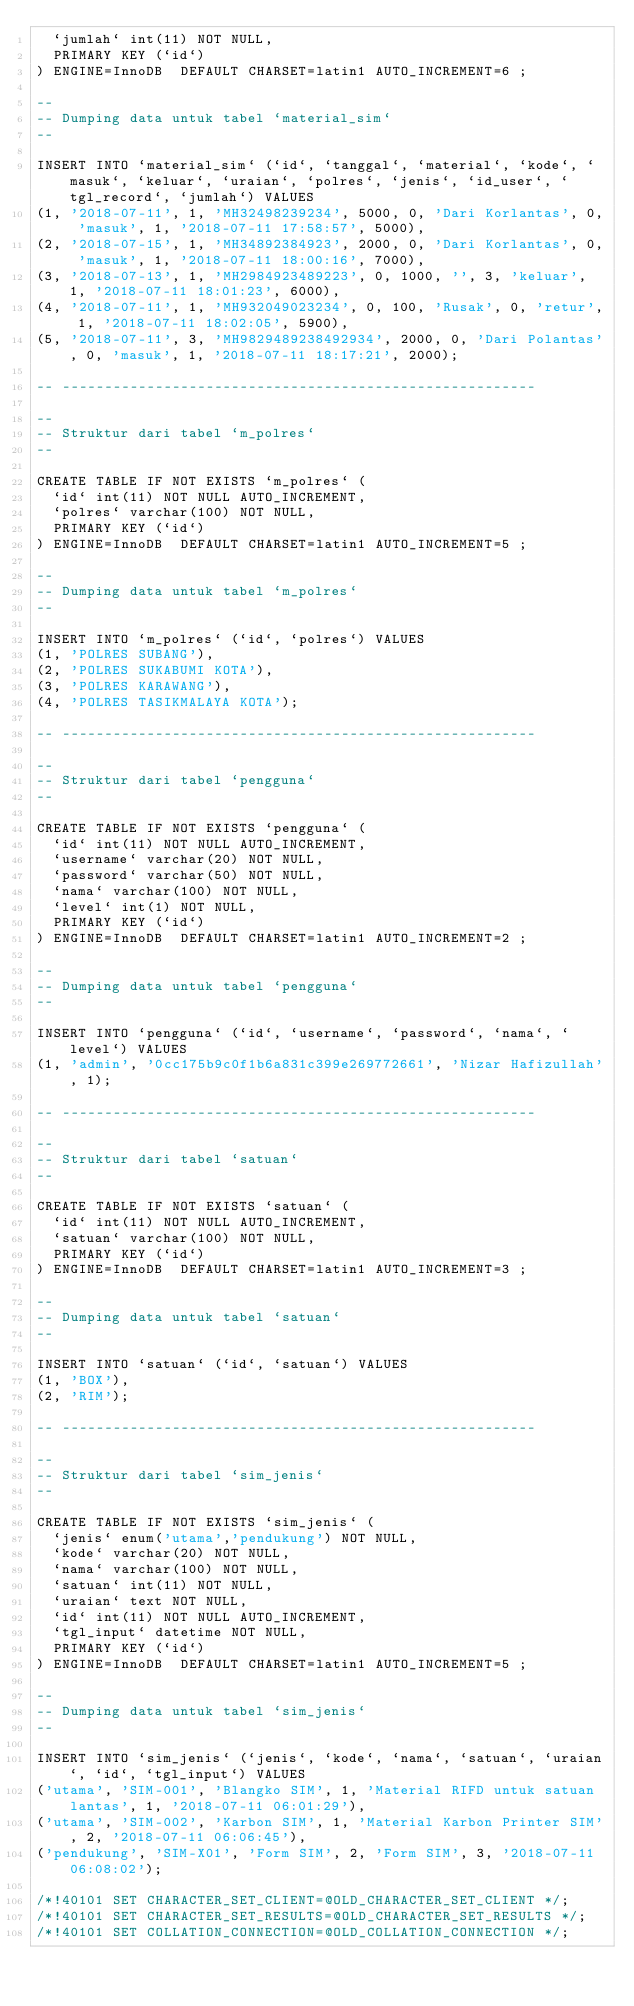Convert code to text. <code><loc_0><loc_0><loc_500><loc_500><_SQL_>  `jumlah` int(11) NOT NULL,
  PRIMARY KEY (`id`)
) ENGINE=InnoDB  DEFAULT CHARSET=latin1 AUTO_INCREMENT=6 ;

--
-- Dumping data untuk tabel `material_sim`
--

INSERT INTO `material_sim` (`id`, `tanggal`, `material`, `kode`, `masuk`, `keluar`, `uraian`, `polres`, `jenis`, `id_user`, `tgl_record`, `jumlah`) VALUES
(1, '2018-07-11', 1, 'MH32498239234', 5000, 0, 'Dari Korlantas', 0, 'masuk', 1, '2018-07-11 17:58:57', 5000),
(2, '2018-07-15', 1, 'MH34892384923', 2000, 0, 'Dari Korlantas', 0, 'masuk', 1, '2018-07-11 18:00:16', 7000),
(3, '2018-07-13', 1, 'MH2984923489223', 0, 1000, '', 3, 'keluar', 1, '2018-07-11 18:01:23', 6000),
(4, '2018-07-11', 1, 'MH932049023234', 0, 100, 'Rusak', 0, 'retur', 1, '2018-07-11 18:02:05', 5900),
(5, '2018-07-11', 3, 'MH9829489238492934', 2000, 0, 'Dari Polantas', 0, 'masuk', 1, '2018-07-11 18:17:21', 2000);

-- --------------------------------------------------------

--
-- Struktur dari tabel `m_polres`
--

CREATE TABLE IF NOT EXISTS `m_polres` (
  `id` int(11) NOT NULL AUTO_INCREMENT,
  `polres` varchar(100) NOT NULL,
  PRIMARY KEY (`id`)
) ENGINE=InnoDB  DEFAULT CHARSET=latin1 AUTO_INCREMENT=5 ;

--
-- Dumping data untuk tabel `m_polres`
--

INSERT INTO `m_polres` (`id`, `polres`) VALUES
(1, 'POLRES SUBANG'),
(2, 'POLRES SUKABUMI KOTA'),
(3, 'POLRES KARAWANG'),
(4, 'POLRES TASIKMALAYA KOTA');

-- --------------------------------------------------------

--
-- Struktur dari tabel `pengguna`
--

CREATE TABLE IF NOT EXISTS `pengguna` (
  `id` int(11) NOT NULL AUTO_INCREMENT,
  `username` varchar(20) NOT NULL,
  `password` varchar(50) NOT NULL,
  `nama` varchar(100) NOT NULL,
  `level` int(1) NOT NULL,
  PRIMARY KEY (`id`)
) ENGINE=InnoDB  DEFAULT CHARSET=latin1 AUTO_INCREMENT=2 ;

--
-- Dumping data untuk tabel `pengguna`
--

INSERT INTO `pengguna` (`id`, `username`, `password`, `nama`, `level`) VALUES
(1, 'admin', '0cc175b9c0f1b6a831c399e269772661', 'Nizar Hafizullah', 1);

-- --------------------------------------------------------

--
-- Struktur dari tabel `satuan`
--

CREATE TABLE IF NOT EXISTS `satuan` (
  `id` int(11) NOT NULL AUTO_INCREMENT,
  `satuan` varchar(100) NOT NULL,
  PRIMARY KEY (`id`)
) ENGINE=InnoDB  DEFAULT CHARSET=latin1 AUTO_INCREMENT=3 ;

--
-- Dumping data untuk tabel `satuan`
--

INSERT INTO `satuan` (`id`, `satuan`) VALUES
(1, 'BOX'),
(2, 'RIM');

-- --------------------------------------------------------

--
-- Struktur dari tabel `sim_jenis`
--

CREATE TABLE IF NOT EXISTS `sim_jenis` (
  `jenis` enum('utama','pendukung') NOT NULL,
  `kode` varchar(20) NOT NULL,
  `nama` varchar(100) NOT NULL,
  `satuan` int(11) NOT NULL,
  `uraian` text NOT NULL,
  `id` int(11) NOT NULL AUTO_INCREMENT,
  `tgl_input` datetime NOT NULL,
  PRIMARY KEY (`id`)
) ENGINE=InnoDB  DEFAULT CHARSET=latin1 AUTO_INCREMENT=5 ;

--
-- Dumping data untuk tabel `sim_jenis`
--

INSERT INTO `sim_jenis` (`jenis`, `kode`, `nama`, `satuan`, `uraian`, `id`, `tgl_input`) VALUES
('utama', 'SIM-001', 'Blangko SIM', 1, 'Material RIFD untuk satuan lantas', 1, '2018-07-11 06:01:29'),
('utama', 'SIM-002', 'Karbon SIM', 1, 'Material Karbon Printer SIM', 2, '2018-07-11 06:06:45'),
('pendukung', 'SIM-X01', 'Form SIM', 2, 'Form SIM', 3, '2018-07-11 06:08:02');

/*!40101 SET CHARACTER_SET_CLIENT=@OLD_CHARACTER_SET_CLIENT */;
/*!40101 SET CHARACTER_SET_RESULTS=@OLD_CHARACTER_SET_RESULTS */;
/*!40101 SET COLLATION_CONNECTION=@OLD_COLLATION_CONNECTION */;
</code> 